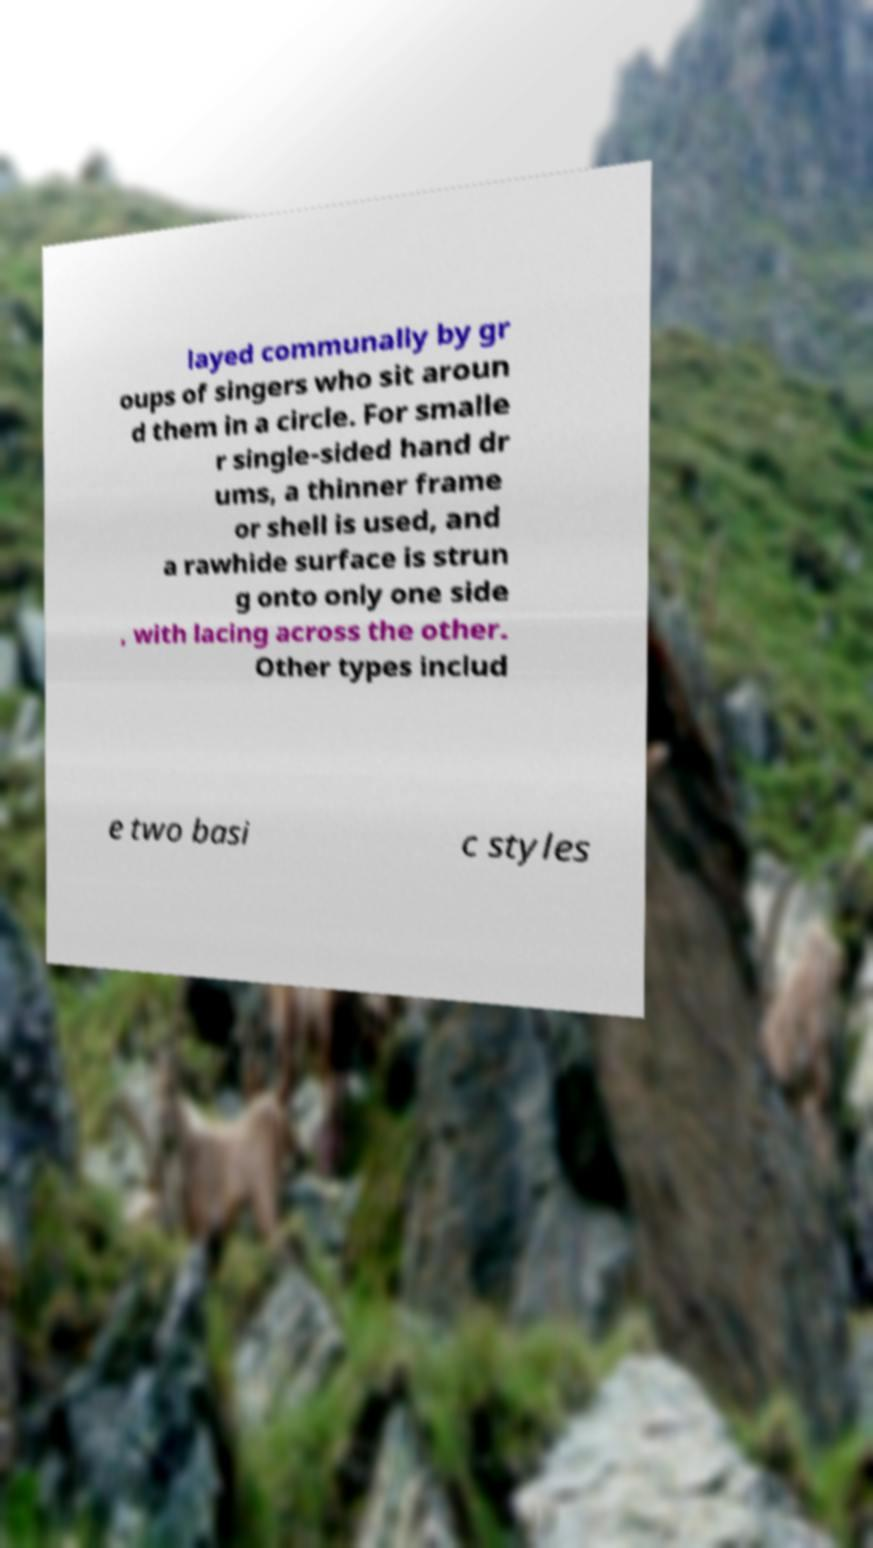I need the written content from this picture converted into text. Can you do that? layed communally by gr oups of singers who sit aroun d them in a circle. For smalle r single-sided hand dr ums, a thinner frame or shell is used, and a rawhide surface is strun g onto only one side , with lacing across the other. Other types includ e two basi c styles 